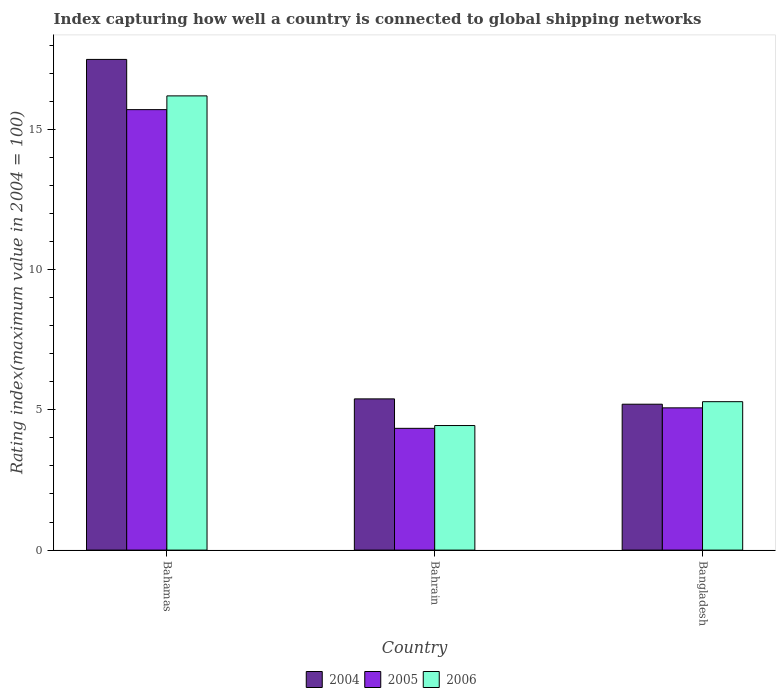How many different coloured bars are there?
Offer a terse response. 3. How many groups of bars are there?
Your response must be concise. 3. Are the number of bars per tick equal to the number of legend labels?
Offer a very short reply. Yes. Are the number of bars on each tick of the X-axis equal?
Offer a terse response. Yes. How many bars are there on the 3rd tick from the left?
Offer a terse response. 3. What is the label of the 3rd group of bars from the left?
Give a very brief answer. Bangladesh. What is the rating index in 2006 in Bangladesh?
Make the answer very short. 5.29. Across all countries, what is the maximum rating index in 2006?
Make the answer very short. 16.19. Across all countries, what is the minimum rating index in 2005?
Offer a terse response. 4.34. In which country was the rating index in 2005 maximum?
Offer a terse response. Bahamas. In which country was the rating index in 2006 minimum?
Provide a succinct answer. Bahrain. What is the total rating index in 2004 in the graph?
Keep it short and to the point. 28.08. What is the difference between the rating index in 2006 in Bahamas and that in Bangladesh?
Give a very brief answer. 10.9. What is the difference between the rating index in 2004 in Bahrain and the rating index in 2005 in Bahamas?
Give a very brief answer. -10.31. What is the average rating index in 2004 per country?
Your answer should be compact. 9.36. What is the difference between the rating index of/in 2004 and rating index of/in 2005 in Bangladesh?
Offer a terse response. 0.13. What is the ratio of the rating index in 2005 in Bahamas to that in Bahrain?
Provide a short and direct response. 3.62. Is the difference between the rating index in 2004 in Bahamas and Bahrain greater than the difference between the rating index in 2005 in Bahamas and Bahrain?
Your answer should be compact. Yes. What is the difference between the highest and the second highest rating index in 2004?
Provide a short and direct response. 12.29. What is the difference between the highest and the lowest rating index in 2005?
Your answer should be compact. 11.36. Is the sum of the rating index in 2005 in Bahrain and Bangladesh greater than the maximum rating index in 2006 across all countries?
Offer a terse response. No. What does the 2nd bar from the left in Bahamas represents?
Offer a terse response. 2005. Is it the case that in every country, the sum of the rating index in 2006 and rating index in 2005 is greater than the rating index in 2004?
Make the answer very short. Yes. How many bars are there?
Give a very brief answer. 9. How many countries are there in the graph?
Your response must be concise. 3. Where does the legend appear in the graph?
Give a very brief answer. Bottom center. How are the legend labels stacked?
Give a very brief answer. Horizontal. What is the title of the graph?
Provide a succinct answer. Index capturing how well a country is connected to global shipping networks. What is the label or title of the X-axis?
Give a very brief answer. Country. What is the label or title of the Y-axis?
Provide a succinct answer. Rating index(maximum value in 2004 = 100). What is the Rating index(maximum value in 2004 = 100) of 2004 in Bahamas?
Offer a very short reply. 17.49. What is the Rating index(maximum value in 2004 = 100) in 2005 in Bahamas?
Keep it short and to the point. 15.7. What is the Rating index(maximum value in 2004 = 100) in 2006 in Bahamas?
Keep it short and to the point. 16.19. What is the Rating index(maximum value in 2004 = 100) in 2004 in Bahrain?
Give a very brief answer. 5.39. What is the Rating index(maximum value in 2004 = 100) in 2005 in Bahrain?
Provide a succinct answer. 4.34. What is the Rating index(maximum value in 2004 = 100) of 2006 in Bahrain?
Your answer should be compact. 4.44. What is the Rating index(maximum value in 2004 = 100) of 2004 in Bangladesh?
Your answer should be compact. 5.2. What is the Rating index(maximum value in 2004 = 100) in 2005 in Bangladesh?
Make the answer very short. 5.07. What is the Rating index(maximum value in 2004 = 100) of 2006 in Bangladesh?
Provide a short and direct response. 5.29. Across all countries, what is the maximum Rating index(maximum value in 2004 = 100) in 2004?
Provide a short and direct response. 17.49. Across all countries, what is the maximum Rating index(maximum value in 2004 = 100) of 2006?
Your answer should be compact. 16.19. Across all countries, what is the minimum Rating index(maximum value in 2004 = 100) in 2004?
Keep it short and to the point. 5.2. Across all countries, what is the minimum Rating index(maximum value in 2004 = 100) in 2005?
Ensure brevity in your answer.  4.34. Across all countries, what is the minimum Rating index(maximum value in 2004 = 100) in 2006?
Provide a short and direct response. 4.44. What is the total Rating index(maximum value in 2004 = 100) in 2004 in the graph?
Your answer should be compact. 28.08. What is the total Rating index(maximum value in 2004 = 100) in 2005 in the graph?
Provide a short and direct response. 25.11. What is the total Rating index(maximum value in 2004 = 100) in 2006 in the graph?
Provide a short and direct response. 25.92. What is the difference between the Rating index(maximum value in 2004 = 100) of 2005 in Bahamas and that in Bahrain?
Your answer should be very brief. 11.36. What is the difference between the Rating index(maximum value in 2004 = 100) in 2006 in Bahamas and that in Bahrain?
Ensure brevity in your answer.  11.75. What is the difference between the Rating index(maximum value in 2004 = 100) in 2004 in Bahamas and that in Bangladesh?
Offer a very short reply. 12.29. What is the difference between the Rating index(maximum value in 2004 = 100) of 2005 in Bahamas and that in Bangladesh?
Offer a terse response. 10.63. What is the difference between the Rating index(maximum value in 2004 = 100) in 2004 in Bahrain and that in Bangladesh?
Provide a short and direct response. 0.19. What is the difference between the Rating index(maximum value in 2004 = 100) in 2005 in Bahrain and that in Bangladesh?
Give a very brief answer. -0.73. What is the difference between the Rating index(maximum value in 2004 = 100) in 2006 in Bahrain and that in Bangladesh?
Offer a very short reply. -0.85. What is the difference between the Rating index(maximum value in 2004 = 100) in 2004 in Bahamas and the Rating index(maximum value in 2004 = 100) in 2005 in Bahrain?
Provide a succinct answer. 13.15. What is the difference between the Rating index(maximum value in 2004 = 100) of 2004 in Bahamas and the Rating index(maximum value in 2004 = 100) of 2006 in Bahrain?
Provide a succinct answer. 13.05. What is the difference between the Rating index(maximum value in 2004 = 100) in 2005 in Bahamas and the Rating index(maximum value in 2004 = 100) in 2006 in Bahrain?
Give a very brief answer. 11.26. What is the difference between the Rating index(maximum value in 2004 = 100) of 2004 in Bahamas and the Rating index(maximum value in 2004 = 100) of 2005 in Bangladesh?
Make the answer very short. 12.42. What is the difference between the Rating index(maximum value in 2004 = 100) of 2005 in Bahamas and the Rating index(maximum value in 2004 = 100) of 2006 in Bangladesh?
Offer a very short reply. 10.41. What is the difference between the Rating index(maximum value in 2004 = 100) of 2004 in Bahrain and the Rating index(maximum value in 2004 = 100) of 2005 in Bangladesh?
Offer a very short reply. 0.32. What is the difference between the Rating index(maximum value in 2004 = 100) of 2004 in Bahrain and the Rating index(maximum value in 2004 = 100) of 2006 in Bangladesh?
Your answer should be very brief. 0.1. What is the difference between the Rating index(maximum value in 2004 = 100) of 2005 in Bahrain and the Rating index(maximum value in 2004 = 100) of 2006 in Bangladesh?
Ensure brevity in your answer.  -0.95. What is the average Rating index(maximum value in 2004 = 100) of 2004 per country?
Your answer should be very brief. 9.36. What is the average Rating index(maximum value in 2004 = 100) in 2005 per country?
Your answer should be very brief. 8.37. What is the average Rating index(maximum value in 2004 = 100) in 2006 per country?
Ensure brevity in your answer.  8.64. What is the difference between the Rating index(maximum value in 2004 = 100) of 2004 and Rating index(maximum value in 2004 = 100) of 2005 in Bahamas?
Give a very brief answer. 1.79. What is the difference between the Rating index(maximum value in 2004 = 100) in 2004 and Rating index(maximum value in 2004 = 100) in 2006 in Bahamas?
Your answer should be very brief. 1.3. What is the difference between the Rating index(maximum value in 2004 = 100) in 2005 and Rating index(maximum value in 2004 = 100) in 2006 in Bahamas?
Provide a short and direct response. -0.49. What is the difference between the Rating index(maximum value in 2004 = 100) of 2004 and Rating index(maximum value in 2004 = 100) of 2006 in Bahrain?
Keep it short and to the point. 0.95. What is the difference between the Rating index(maximum value in 2004 = 100) of 2004 and Rating index(maximum value in 2004 = 100) of 2005 in Bangladesh?
Your response must be concise. 0.13. What is the difference between the Rating index(maximum value in 2004 = 100) of 2004 and Rating index(maximum value in 2004 = 100) of 2006 in Bangladesh?
Provide a short and direct response. -0.09. What is the difference between the Rating index(maximum value in 2004 = 100) in 2005 and Rating index(maximum value in 2004 = 100) in 2006 in Bangladesh?
Offer a very short reply. -0.22. What is the ratio of the Rating index(maximum value in 2004 = 100) of 2004 in Bahamas to that in Bahrain?
Your response must be concise. 3.24. What is the ratio of the Rating index(maximum value in 2004 = 100) in 2005 in Bahamas to that in Bahrain?
Offer a terse response. 3.62. What is the ratio of the Rating index(maximum value in 2004 = 100) in 2006 in Bahamas to that in Bahrain?
Offer a terse response. 3.65. What is the ratio of the Rating index(maximum value in 2004 = 100) of 2004 in Bahamas to that in Bangladesh?
Make the answer very short. 3.36. What is the ratio of the Rating index(maximum value in 2004 = 100) in 2005 in Bahamas to that in Bangladesh?
Your response must be concise. 3.1. What is the ratio of the Rating index(maximum value in 2004 = 100) in 2006 in Bahamas to that in Bangladesh?
Give a very brief answer. 3.06. What is the ratio of the Rating index(maximum value in 2004 = 100) in 2004 in Bahrain to that in Bangladesh?
Provide a succinct answer. 1.04. What is the ratio of the Rating index(maximum value in 2004 = 100) in 2005 in Bahrain to that in Bangladesh?
Your answer should be compact. 0.86. What is the ratio of the Rating index(maximum value in 2004 = 100) of 2006 in Bahrain to that in Bangladesh?
Your answer should be very brief. 0.84. What is the difference between the highest and the second highest Rating index(maximum value in 2004 = 100) in 2005?
Your answer should be very brief. 10.63. What is the difference between the highest and the second highest Rating index(maximum value in 2004 = 100) in 2006?
Give a very brief answer. 10.9. What is the difference between the highest and the lowest Rating index(maximum value in 2004 = 100) of 2004?
Ensure brevity in your answer.  12.29. What is the difference between the highest and the lowest Rating index(maximum value in 2004 = 100) in 2005?
Offer a terse response. 11.36. What is the difference between the highest and the lowest Rating index(maximum value in 2004 = 100) in 2006?
Offer a very short reply. 11.75. 